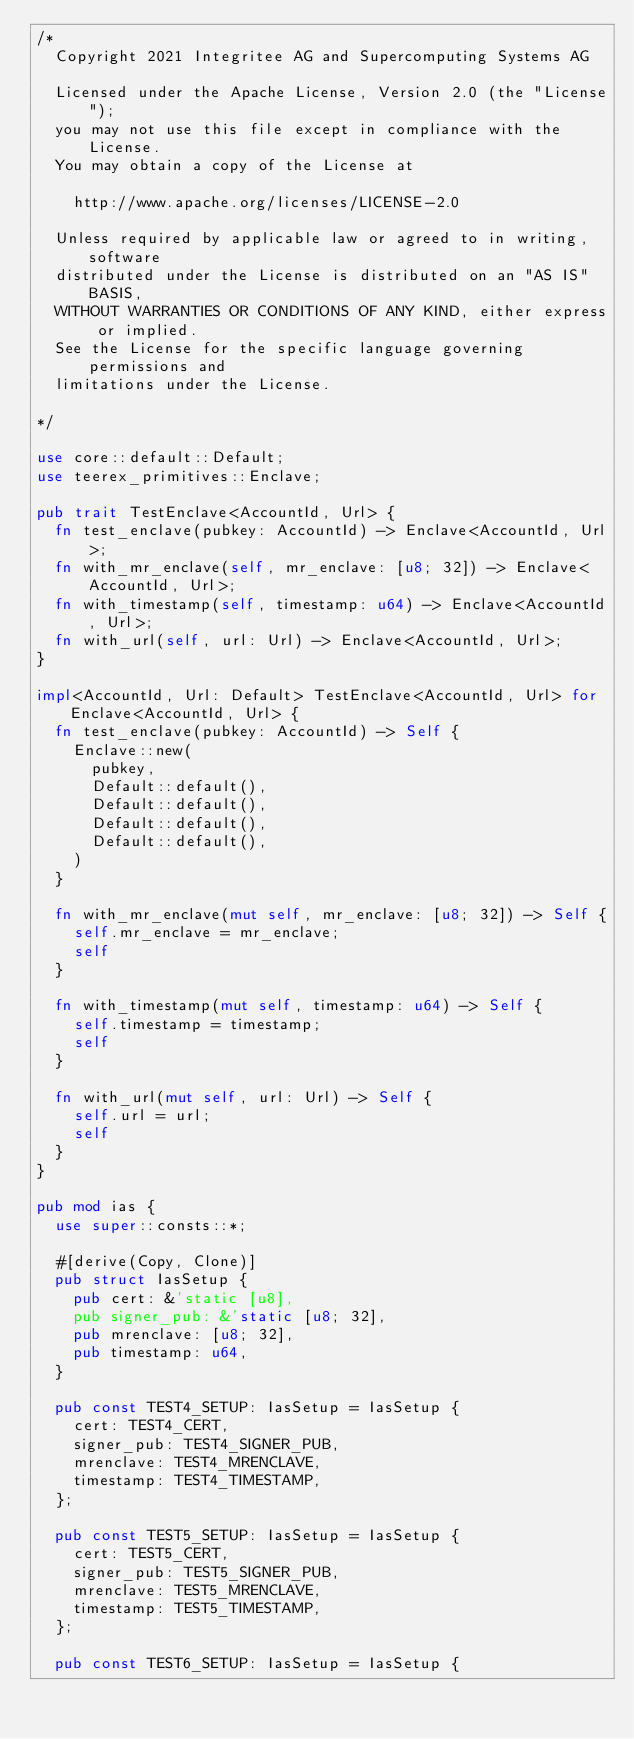<code> <loc_0><loc_0><loc_500><loc_500><_Rust_>/*
	Copyright 2021 Integritee AG and Supercomputing Systems AG

	Licensed under the Apache License, Version 2.0 (the "License");
	you may not use this file except in compliance with the License.
	You may obtain a copy of the License at

		http://www.apache.org/licenses/LICENSE-2.0

	Unless required by applicable law or agreed to in writing, software
	distributed under the License is distributed on an "AS IS" BASIS,
	WITHOUT WARRANTIES OR CONDITIONS OF ANY KIND, either express or implied.
	See the License for the specific language governing permissions and
	limitations under the License.

*/

use core::default::Default;
use teerex_primitives::Enclave;

pub trait TestEnclave<AccountId, Url> {
	fn test_enclave(pubkey: AccountId) -> Enclave<AccountId, Url>;
	fn with_mr_enclave(self, mr_enclave: [u8; 32]) -> Enclave<AccountId, Url>;
	fn with_timestamp(self, timestamp: u64) -> Enclave<AccountId, Url>;
	fn with_url(self, url: Url) -> Enclave<AccountId, Url>;
}

impl<AccountId, Url: Default> TestEnclave<AccountId, Url> for Enclave<AccountId, Url> {
	fn test_enclave(pubkey: AccountId) -> Self {
		Enclave::new(
			pubkey,
			Default::default(),
			Default::default(),
			Default::default(),
			Default::default(),
		)
	}

	fn with_mr_enclave(mut self, mr_enclave: [u8; 32]) -> Self {
		self.mr_enclave = mr_enclave;
		self
	}

	fn with_timestamp(mut self, timestamp: u64) -> Self {
		self.timestamp = timestamp;
		self
	}

	fn with_url(mut self, url: Url) -> Self {
		self.url = url;
		self
	}
}

pub mod ias {
	use super::consts::*;

	#[derive(Copy, Clone)]
	pub struct IasSetup {
		pub cert: &'static [u8],
		pub signer_pub: &'static [u8; 32],
		pub mrenclave: [u8; 32],
		pub timestamp: u64,
	}

	pub const TEST4_SETUP: IasSetup = IasSetup {
		cert: TEST4_CERT,
		signer_pub: TEST4_SIGNER_PUB,
		mrenclave: TEST4_MRENCLAVE,
		timestamp: TEST4_TIMESTAMP,
	};

	pub const TEST5_SETUP: IasSetup = IasSetup {
		cert: TEST5_CERT,
		signer_pub: TEST5_SIGNER_PUB,
		mrenclave: TEST5_MRENCLAVE,
		timestamp: TEST5_TIMESTAMP,
	};

	pub const TEST6_SETUP: IasSetup = IasSetup {</code> 